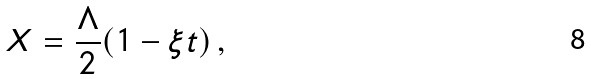Convert formula to latex. <formula><loc_0><loc_0><loc_500><loc_500>X = \frac { \Lambda } { 2 } ( 1 - \xi t ) \, ,</formula> 